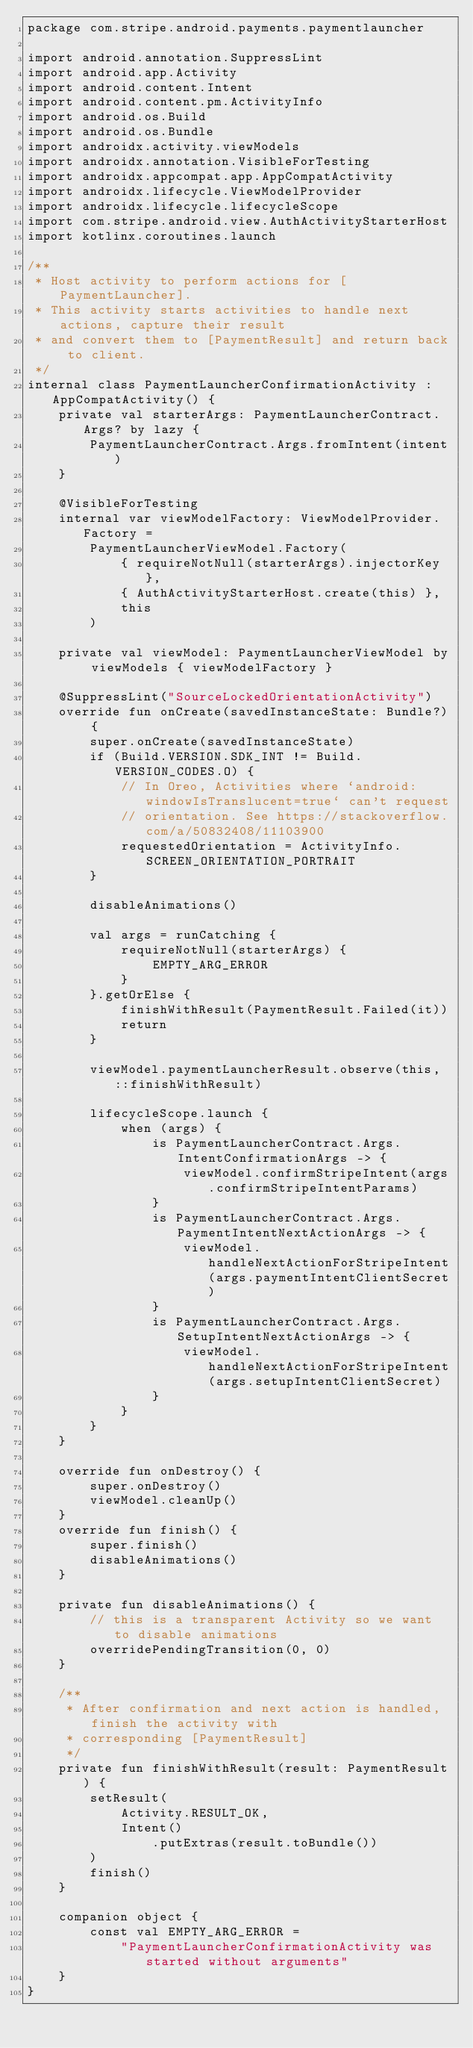Convert code to text. <code><loc_0><loc_0><loc_500><loc_500><_Kotlin_>package com.stripe.android.payments.paymentlauncher

import android.annotation.SuppressLint
import android.app.Activity
import android.content.Intent
import android.content.pm.ActivityInfo
import android.os.Build
import android.os.Bundle
import androidx.activity.viewModels
import androidx.annotation.VisibleForTesting
import androidx.appcompat.app.AppCompatActivity
import androidx.lifecycle.ViewModelProvider
import androidx.lifecycle.lifecycleScope
import com.stripe.android.view.AuthActivityStarterHost
import kotlinx.coroutines.launch

/**
 * Host activity to perform actions for [PaymentLauncher].
 * This activity starts activities to handle next actions, capture their result
 * and convert them to [PaymentResult] and return back to client.
 */
internal class PaymentLauncherConfirmationActivity : AppCompatActivity() {
    private val starterArgs: PaymentLauncherContract.Args? by lazy {
        PaymentLauncherContract.Args.fromIntent(intent)
    }

    @VisibleForTesting
    internal var viewModelFactory: ViewModelProvider.Factory =
        PaymentLauncherViewModel.Factory(
            { requireNotNull(starterArgs).injectorKey },
            { AuthActivityStarterHost.create(this) },
            this
        )

    private val viewModel: PaymentLauncherViewModel by viewModels { viewModelFactory }

    @SuppressLint("SourceLockedOrientationActivity")
    override fun onCreate(savedInstanceState: Bundle?) {
        super.onCreate(savedInstanceState)
        if (Build.VERSION.SDK_INT != Build.VERSION_CODES.O) {
            // In Oreo, Activities where `android:windowIsTranslucent=true` can't request
            // orientation. See https://stackoverflow.com/a/50832408/11103900
            requestedOrientation = ActivityInfo.SCREEN_ORIENTATION_PORTRAIT
        }

        disableAnimations()

        val args = runCatching {
            requireNotNull(starterArgs) {
                EMPTY_ARG_ERROR
            }
        }.getOrElse {
            finishWithResult(PaymentResult.Failed(it))
            return
        }

        viewModel.paymentLauncherResult.observe(this, ::finishWithResult)

        lifecycleScope.launch {
            when (args) {
                is PaymentLauncherContract.Args.IntentConfirmationArgs -> {
                    viewModel.confirmStripeIntent(args.confirmStripeIntentParams)
                }
                is PaymentLauncherContract.Args.PaymentIntentNextActionArgs -> {
                    viewModel.handleNextActionForStripeIntent(args.paymentIntentClientSecret)
                }
                is PaymentLauncherContract.Args.SetupIntentNextActionArgs -> {
                    viewModel.handleNextActionForStripeIntent(args.setupIntentClientSecret)
                }
            }
        }
    }

    override fun onDestroy() {
        super.onDestroy()
        viewModel.cleanUp()
    }
    override fun finish() {
        super.finish()
        disableAnimations()
    }

    private fun disableAnimations() {
        // this is a transparent Activity so we want to disable animations
        overridePendingTransition(0, 0)
    }

    /**
     * After confirmation and next action is handled, finish the activity with
     * corresponding [PaymentResult]
     */
    private fun finishWithResult(result: PaymentResult) {
        setResult(
            Activity.RESULT_OK,
            Intent()
                .putExtras(result.toBundle())
        )
        finish()
    }

    companion object {
        const val EMPTY_ARG_ERROR =
            "PaymentLauncherConfirmationActivity was started without arguments"
    }
}
</code> 